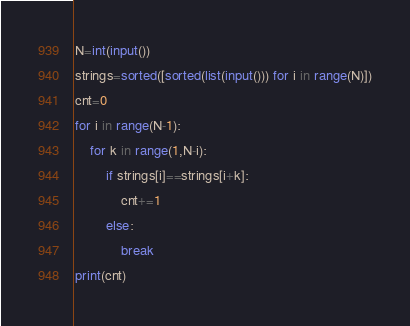<code> <loc_0><loc_0><loc_500><loc_500><_Python_>N=int(input())
strings=sorted([sorted(list(input())) for i in range(N)])
cnt=0
for i in range(N-1):
    for k in range(1,N-i):
        if strings[i]==strings[i+k]:
            cnt+=1
        else:
            break
print(cnt)</code> 